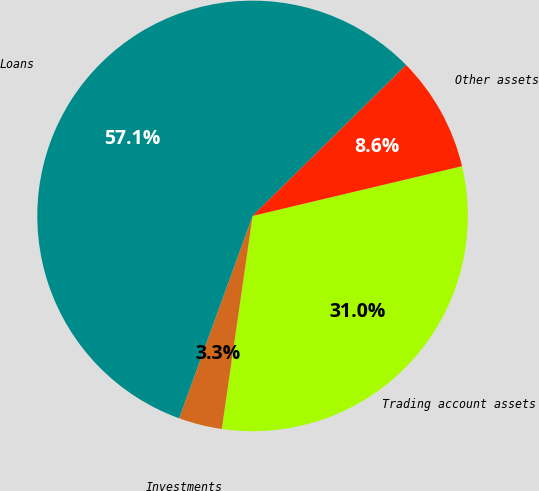<chart> <loc_0><loc_0><loc_500><loc_500><pie_chart><fcel>Trading account assets<fcel>Investments<fcel>Loans<fcel>Other assets<nl><fcel>31.0%<fcel>3.26%<fcel>57.1%<fcel>8.65%<nl></chart> 